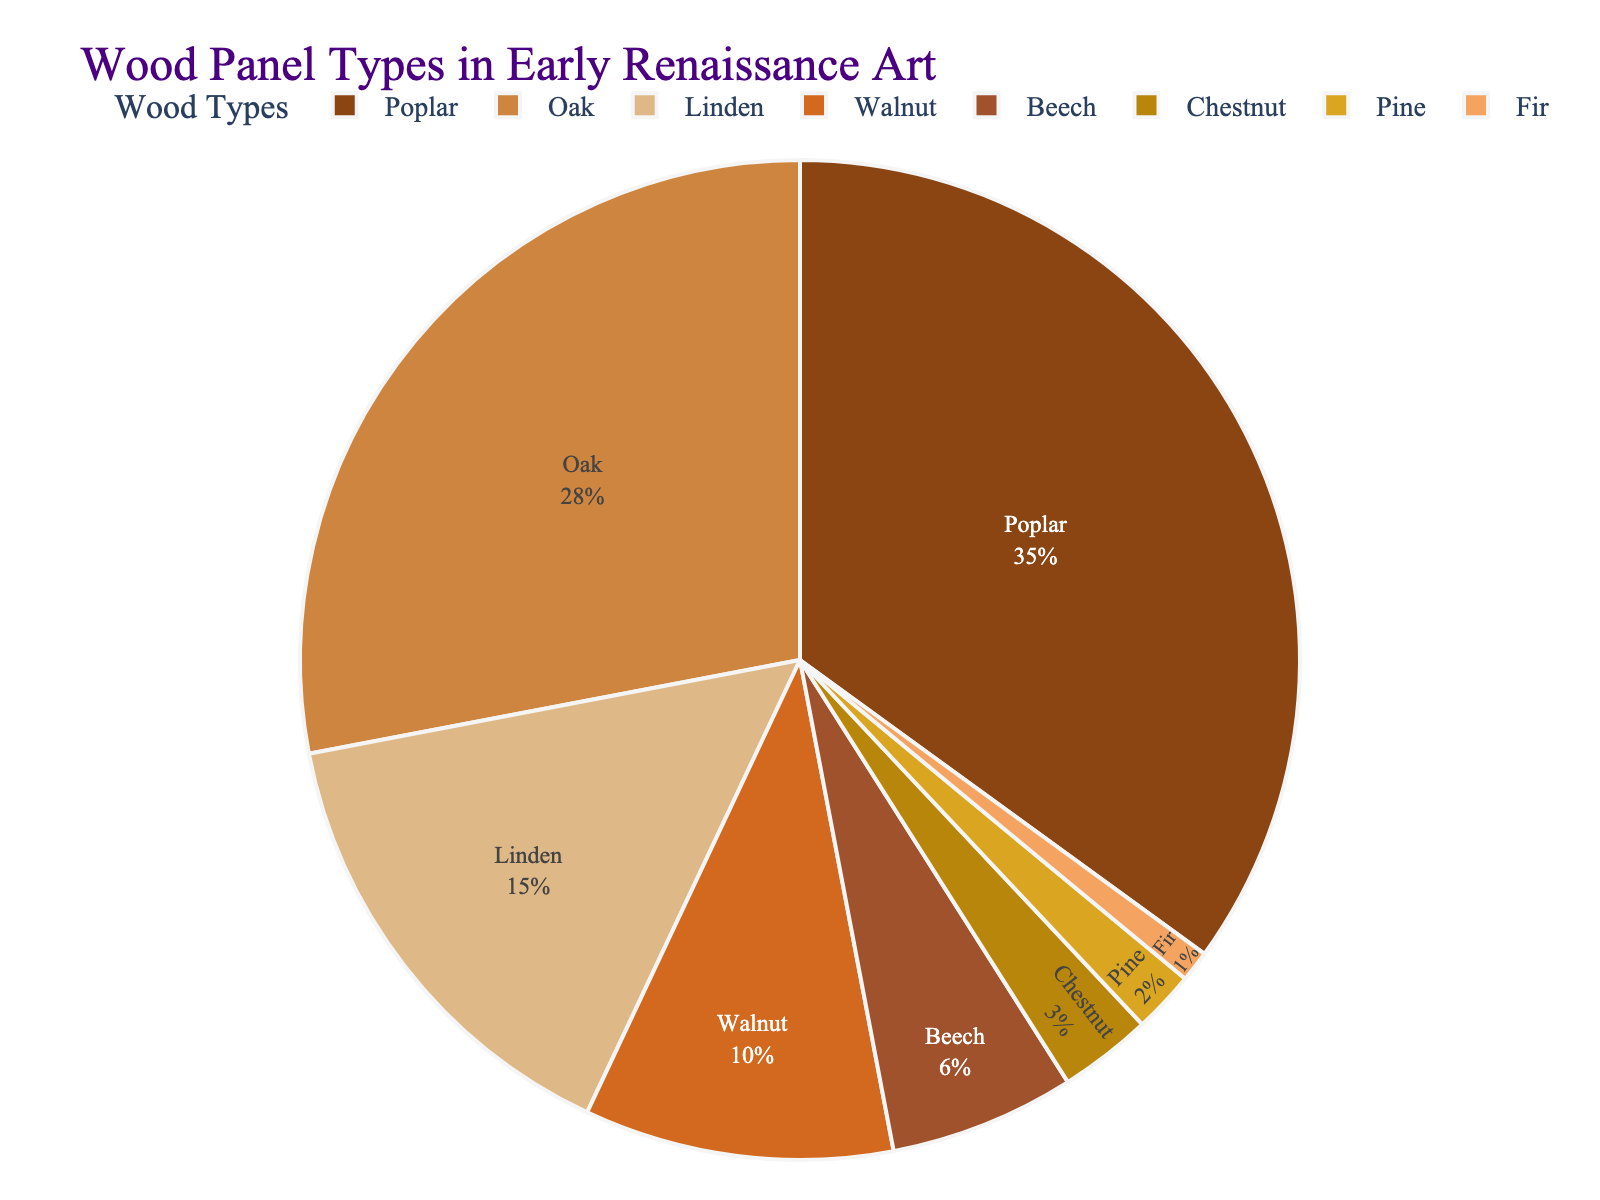What's the most commonly used wood type in early Renaissance art? The largest segment of the pie chart represents the most commonly used wood type. By observing the chart, the segment labeled "Poplar" is the largest.
Answer: Poplar What percentage of wood panels are made from Poplar and Oak combined? The percentage of Poplar is 35%, and the percentage of Oak is 28%. Adding these together gives 35 + 28 = 63%.
Answer: 63% How does the percentage of Linden compare to the percentage of Walnut? The pie chart shows that Linden accounts for 15%, and Walnut accounts for 10%. Therefore, Linden is 5% more than Walnut.
Answer: Linden is 5% more Which wood type is the least used in early Renaissance art? The smallest segment of the pie chart represents the least used wood type, which is labeled as "Fir" with a percentage of 1%.
Answer: Fir Are there more panels made from Beech or Chestnut? The chart shows that Beech accounts for 6% and Chestnut for 3%. Beech is, therefore, more commonly used than Chestnut.
Answer: Beech What's the combined percentage of the least three used wood types? Fir (1%), Pine (2%), and Chestnut (3%) are the three least used wood types. Their combined percentage is 1 + 2 + 3 = 6%.
Answer: 6% What is the difference in percentage between the most and least used wood types? The most used wood type is Poplar at 35%, and the least used is Fir at 1%. The difference is 35 - 1 = 34%.
Answer: 34% Which wood type accounts for slightly less than half of the usage of Oak? Oak accounts for 28%. Linden, which accounts for 15%, is just slightly over half of Oak's percentage but is the closest match to half of Oak compared to other wood types.
Answer: Linden If the percentages for Pine and Chestnut were combined, would they surpass Walnut in usage? Pine accounts for 2% and Chestnut for 3%. Their combined percentage is 2 + 3 = 5%, which is lower than Walnut's 10%.
Answer: No What color is used to represent Beech in the pie chart? The segment labeled "Beech" appears in the contextually brownish-golden colors inspired by Renaissance art but exact visualization can't be determined from data provided.
Answer: Brownish-golden 